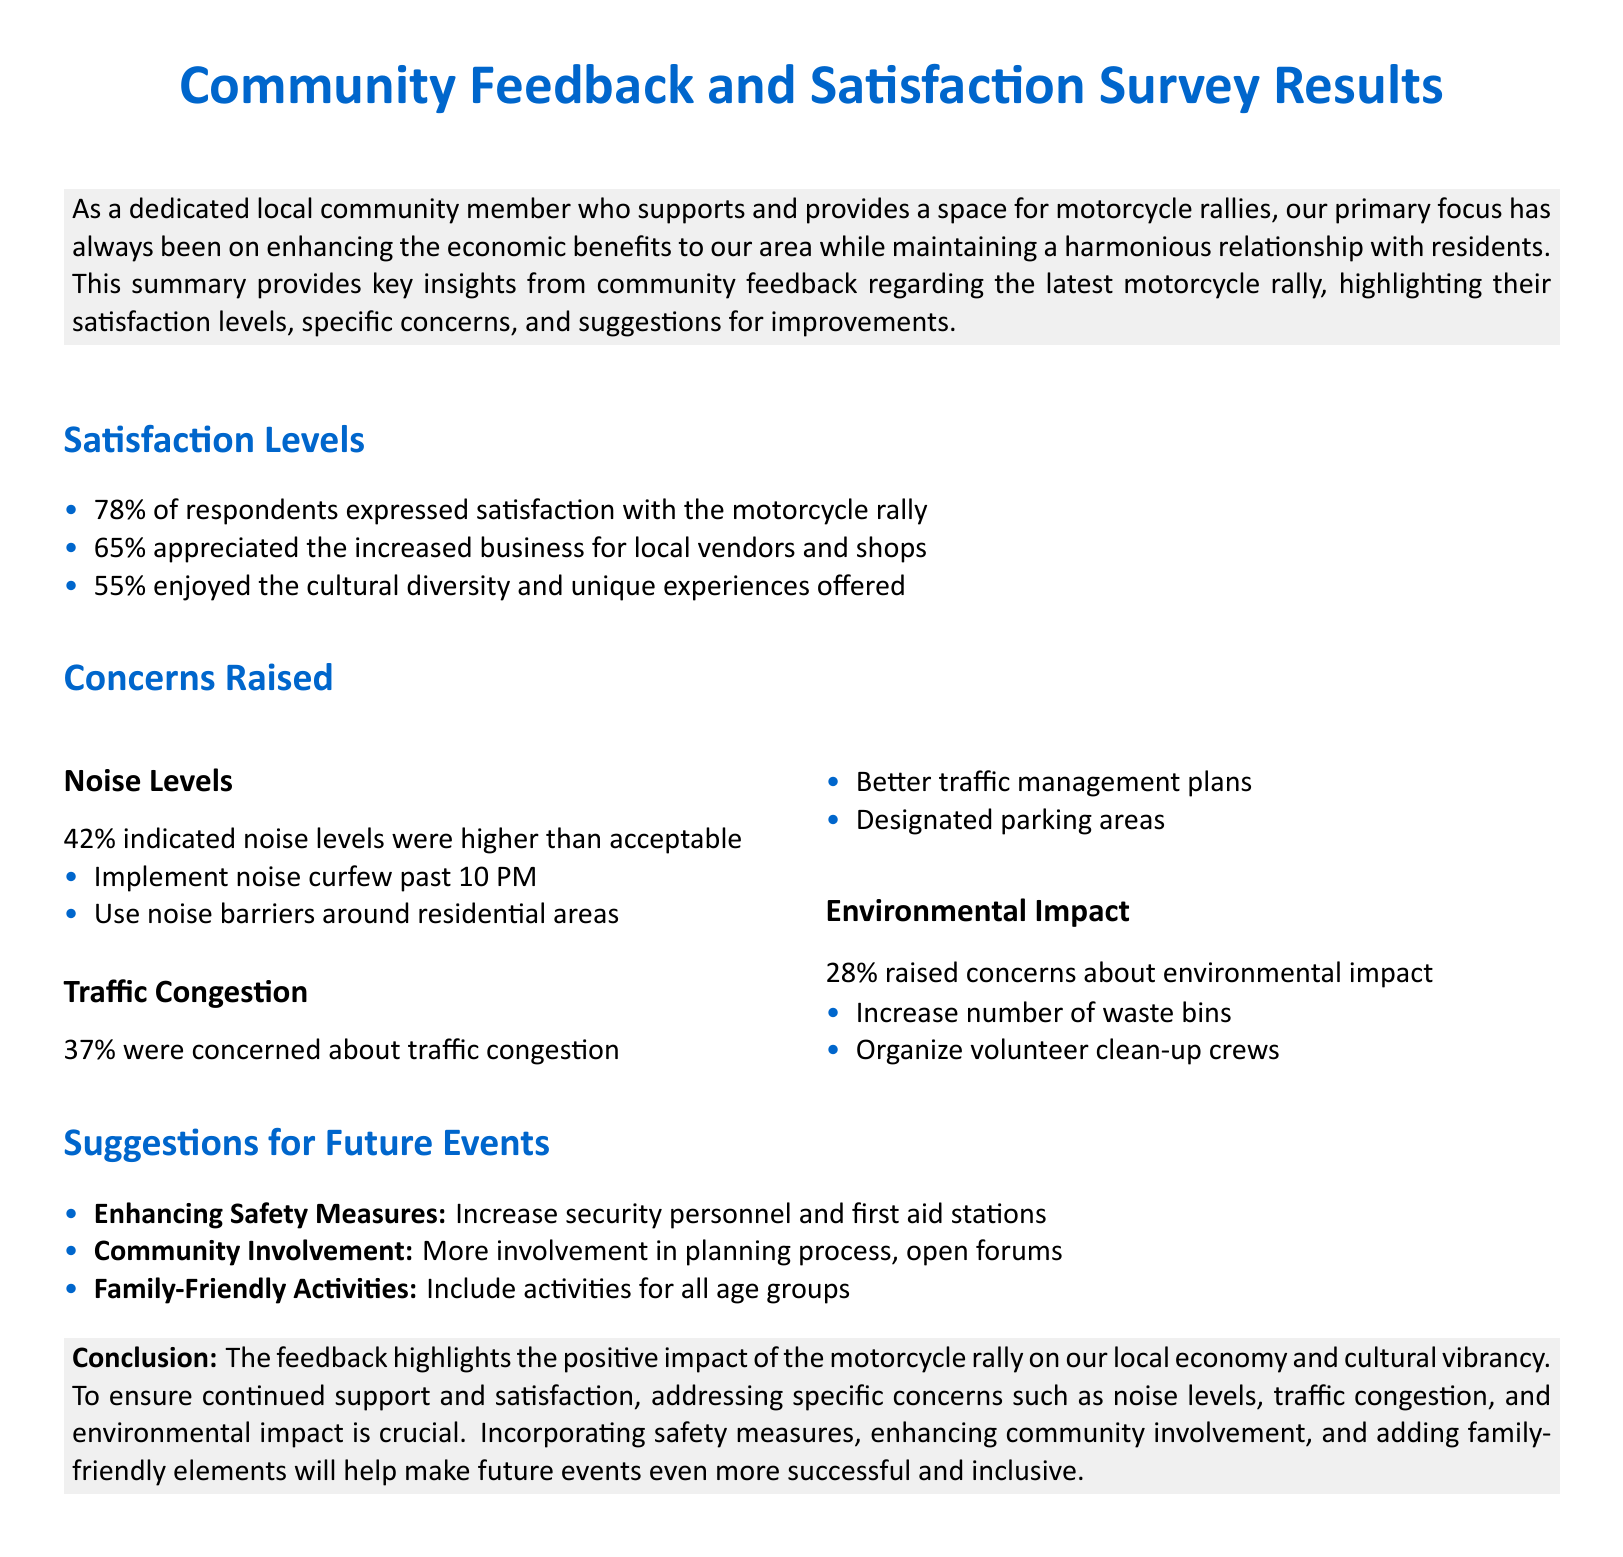What percentage of respondents expressed satisfaction with the motorcycle rally? The document states that 78% of respondents expressed satisfaction.
Answer: 78% What percentage of respondents appreciated the increased business for local vendors and shops? The document mentions that 65% appreciated the increased business for local vendors and shops.
Answer: 65% What concern was raised by 42% of respondents? The document identifies noise levels as a concern raised by 42% of respondents.
Answer: Noise levels What is one suggestion made for addressing traffic congestion? A suggestion made in the document for traffic congestion is better traffic management plans.
Answer: Better traffic management plans What specific action is recommended to enhance safety measures for future events? The document recommends increasing security personnel as a specific action to enhance safety measures.
Answer: Increase security personnel What impact does the motorcycle rally reportedly have on the local economy? The document notes a positive impact on the local economy.
Answer: Positive impact How many respondents raised concerns related to environmental impact? The document states that 28% raised concerns about environmental impact.
Answer: 28% What type of activities is suggested to be included for family-friendly elements? The document suggests including activities for all age groups as family-friendly elements.
Answer: Activities for all age groups What was the overall conclusion drawn from the community feedback? The document concludes that the feedback highlights the positive impact of the motorcycle rally and identifies areas for improvement.
Answer: Positive impact and areas for improvement 